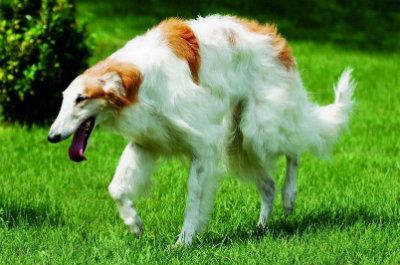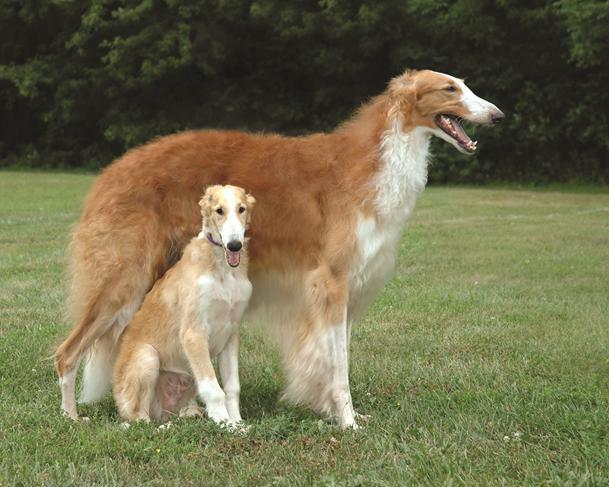The first image is the image on the left, the second image is the image on the right. Evaluate the accuracy of this statement regarding the images: "There are two dogs". Is it true? Answer yes or no. No. The first image is the image on the left, the second image is the image on the right. Considering the images on both sides, is "An image shows two hounds interacting face-to-face." valid? Answer yes or no. No. The first image is the image on the left, the second image is the image on the right. Given the left and right images, does the statement "Two dogs are facing each other in one of the images." hold true? Answer yes or no. No. 